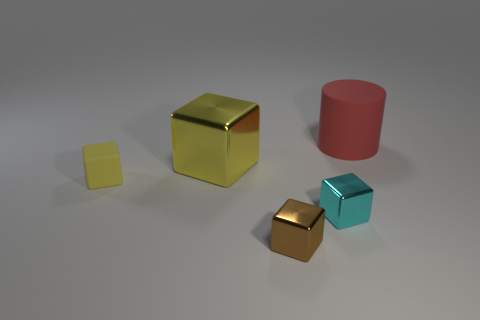Subtract 2 cubes. How many cubes are left? 2 Subtract all brown cubes. How many cubes are left? 3 Subtract all shiny cubes. How many cubes are left? 1 Subtract all green blocks. Subtract all green cylinders. How many blocks are left? 4 Add 2 big gray shiny balls. How many objects exist? 7 Subtract all cylinders. How many objects are left? 4 Subtract all big red matte cylinders. Subtract all big purple rubber objects. How many objects are left? 4 Add 2 yellow rubber cubes. How many yellow rubber cubes are left? 3 Add 5 large purple matte cylinders. How many large purple matte cylinders exist? 5 Subtract 0 gray cubes. How many objects are left? 5 